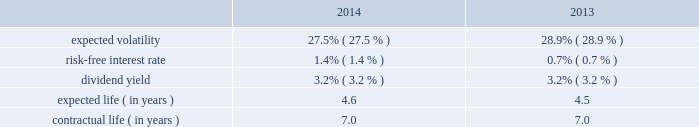Republic services , inc .
Notes to consolidated financial statements 2014 ( continued ) 11 .
Employee benefit plans stock-based compensation in february 2007 , our board of directors approved the 2007 stock incentive plan ( 2007 plan ) , and in may 2007 our shareholders ratified the 2007 plan .
In march 2011 , our board of directors approved the amended and restated 2007 stock incentive plan , and in may 2011 our shareholders ratified the amended and restated 2007 stock incentive plan .
In march 2013 , our board of directors approved the republic services , inc .
Amended and restated 2007 stock incentive plan ( the amended and restated plan ) , and in may 2013 our shareholders ratified the amended and restated plan .
We currently have approximately 15.6 million shares of common stock reserved for future grants under the amended and restated plan .
Options granted under the 2007 plan and the amended and restated plan are non-qualified and are granted at a price equal to the fair market value of our common stock at the date of grant .
Generally , options granted have a term of seven to ten years from the date of grant , and vest in increments of 25% ( 25 % ) per year over a period of four years beginning on the first anniversary date of the grant .
Options granted to non-employee directors have a term of ten years and are fully vested at the grant date .
In december 2008 , the board of directors amended and restated the republic services , inc .
2006 incentive stock plan ( formerly known as the allied waste industries , inc .
2006 incentive stock plan ) ( the 2006 plan ) .
Allied 2019s shareholders approved the 2006 plan in may 2006 .
The 2006 plan was amended and restated in december 2008 to reflect republic as the new sponsor of the plan , to reflect that any references to shares of common stock are to shares of common stock of republic , and to adjust outstanding awards and the number of shares available under the plan to reflect the allied acquisition .
The 2006 plan , as amended and restated , provided for the grant of non- qualified stock options , incentive stock options , shares of restricted stock , shares of phantom stock , stock bonuses , restricted stock units , stock appreciation rights , performance awards , dividend equivalents , cash awards , or other stock-based awards .
Awards granted under the 2006 plan prior to december 5 , 2008 became fully vested and nonforfeitable upon the closing of the allied acquisition .
No further awards will be made under the 2006 stock options we use a lattice binomial option-pricing model to value our stock option grants .
We recognize compensation expense on a straight-line basis over the requisite service period for each separately vesting portion of the award , or to the employee 2019s retirement eligible date , if earlier .
Expected volatility is based on the weighted average of the most recent one year volatility and a historical rolling average volatility of our stock over the expected life of the option .
The risk-free interest rate is based on federal reserve rates in effect for bonds with maturity dates equal to the expected term of the option .
We use historical data to estimate future option exercises , forfeitures ( at 3.0% ( 3.0 % ) for 2014 and 2013 ) and expected life of the options .
When appropriate , separate groups of employees that have similar historical exercise behavior are considered separately for valuation purposes .
We did not grant stock options during the year ended december 31 , 2015 .
The weighted-average estimated fair values of stock options granted during the years ended december 31 , 2014 and 2013 were $ 5.74 and $ 5.27 per option , respectively , which were calculated using the following weighted-average assumptions: .

What was the percentage change in the weighted-average estimated fair values of stock options granted from 2013 and 2014? 
Rationale: the percentage change in the weighted-average estimated fair values of stock options granted from 2013 and 2014 was 8.9%
Computations: ((5.74 - 5.27) / 5.27)
Answer: 0.08918. 